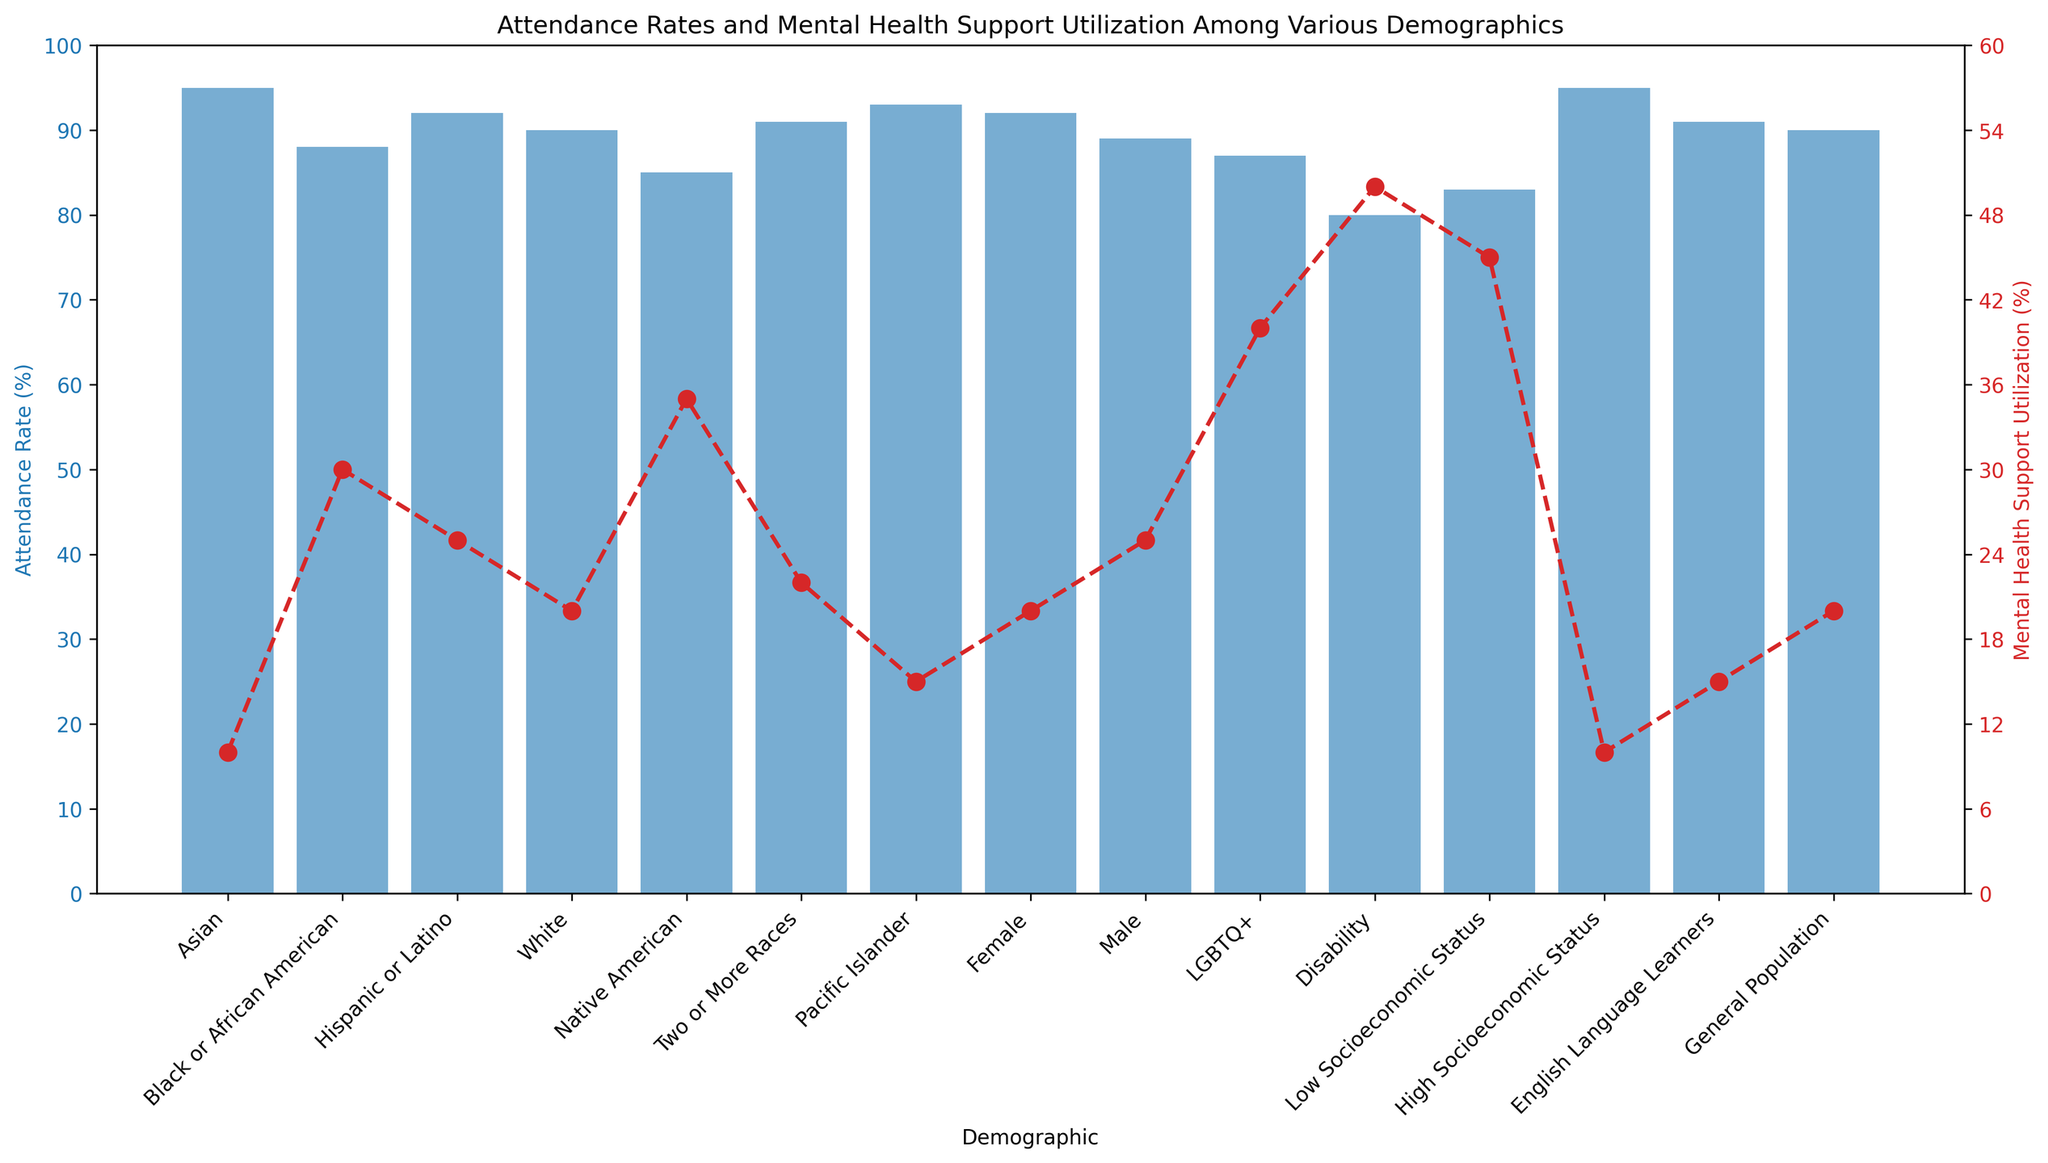What demographic has the highest attendance rate? The figure shows the attendance rates by demographic on a blue bar graph. The demographic with the longest blue bar represents the highest attendance rate.
Answer: Asian (and High Socioeconomic Status) What is the attendance rate difference between the general population and students with disabilities? Locate the attendance rates for the general population and students with disabilities and then subtract the two values: 90% (General Population) - 80% (Disability) = 10%.
Answer: 10% Which demographic utilizes mental health support the most? The figure shows mental health support utilization by demographic on a red line graph with markers. The demographic with the highest red marker represents the highest utilization rate.
Answer: Disability What is the average mental health support utilization rate for the demographics with attendance rates above 90%? Identify the demographics with attendance rates above 90% (Asian, Hispanic or Latino, Pacific Islander, Female, High Socioeconomic Status, English Language Learners). Calculate the average of their mental health support utilization rates: (10 + 25 + 15 + 20 + 10 + 15) / 6 = 15.83%.
Answer: 15.83% Do more males or females utilize mental health support? Compare the red markers for males and females in the mental health support utilization line graph.
Answer: Males Which demographic has the smallest gap between attendance rate and mental health support utilization? Calculate the gap for each demographic by subtracting mental health support utilization from attendance rate and identify the smallest resulting value:
Answer: Female (92% - 20% = 72%) What is the attendance rate for demographics with mental health support utilization of 15% or more? Identify demographics with 15% or more mental health support utilization and list their attendance rates: Black or African American (88%), Hispanic or Latino (92%), White (90%), Native American (85%), Two or More Races (91%), Male (89%), LGBTQ+ (87%), Disability (80%), Low Socioeconomic Status (83%), English Language Learners (91%)
Answer: Various rates listed Which two demographics have the closest mental health support utilization rates? Compare the red markers for all demographics and find those with the closest values.
Answer: Hispanic or Latino and Two or More Races (25% and 22%) Is the general population's attendance rate higher or lower than Native American students'? Compare the height of the blue bars for the general population and Native American students.
Answer: Higher (General Population 90%, Native American 85%) How many demographics have an attendance rate equal to or higher than 90%? Count the number of blue bars that reach or exceed the 90% attendance rate mark on the bar graph.
Answer: 7 